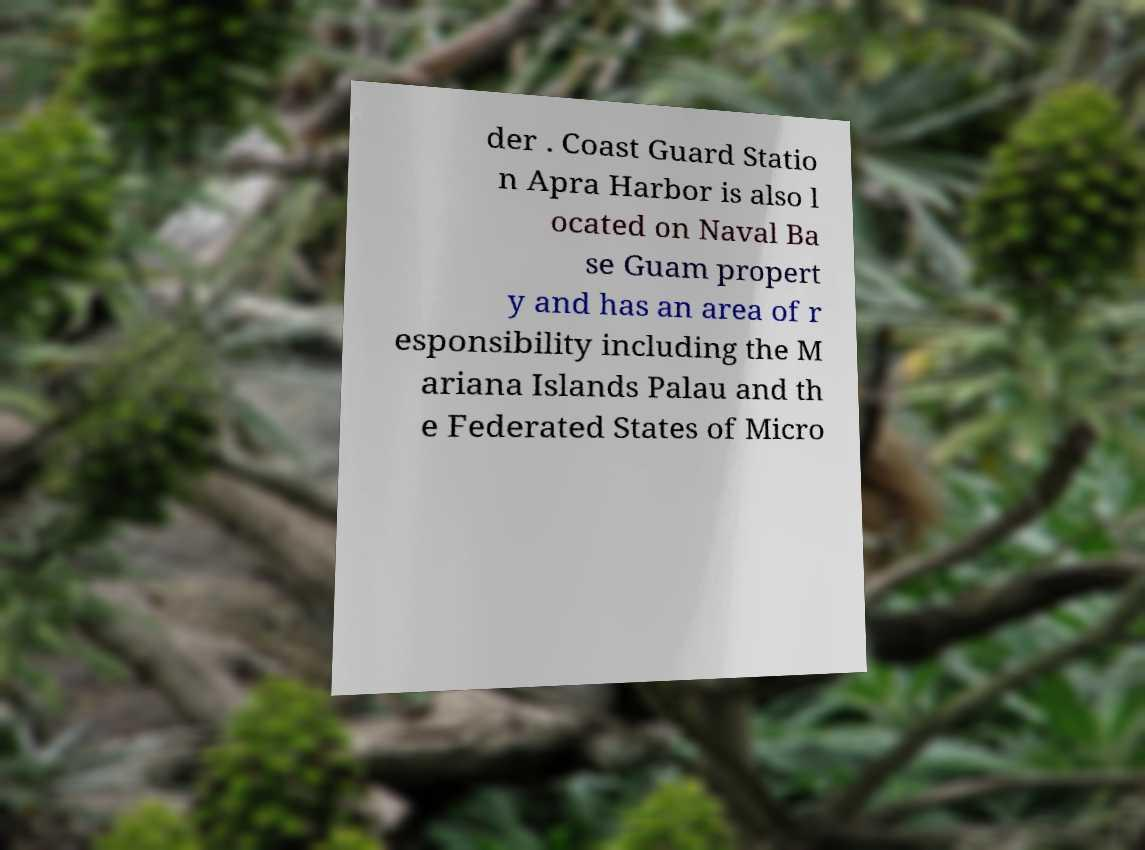Could you assist in decoding the text presented in this image and type it out clearly? der . Coast Guard Statio n Apra Harbor is also l ocated on Naval Ba se Guam propert y and has an area of r esponsibility including the M ariana Islands Palau and th e Federated States of Micro 